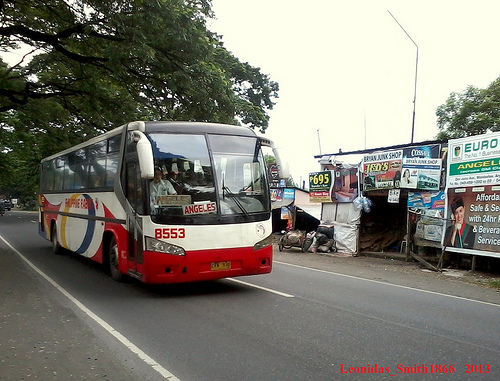<image>
Is the road under the bus? Yes. The road is positioned underneath the bus, with the bus above it in the vertical space. 